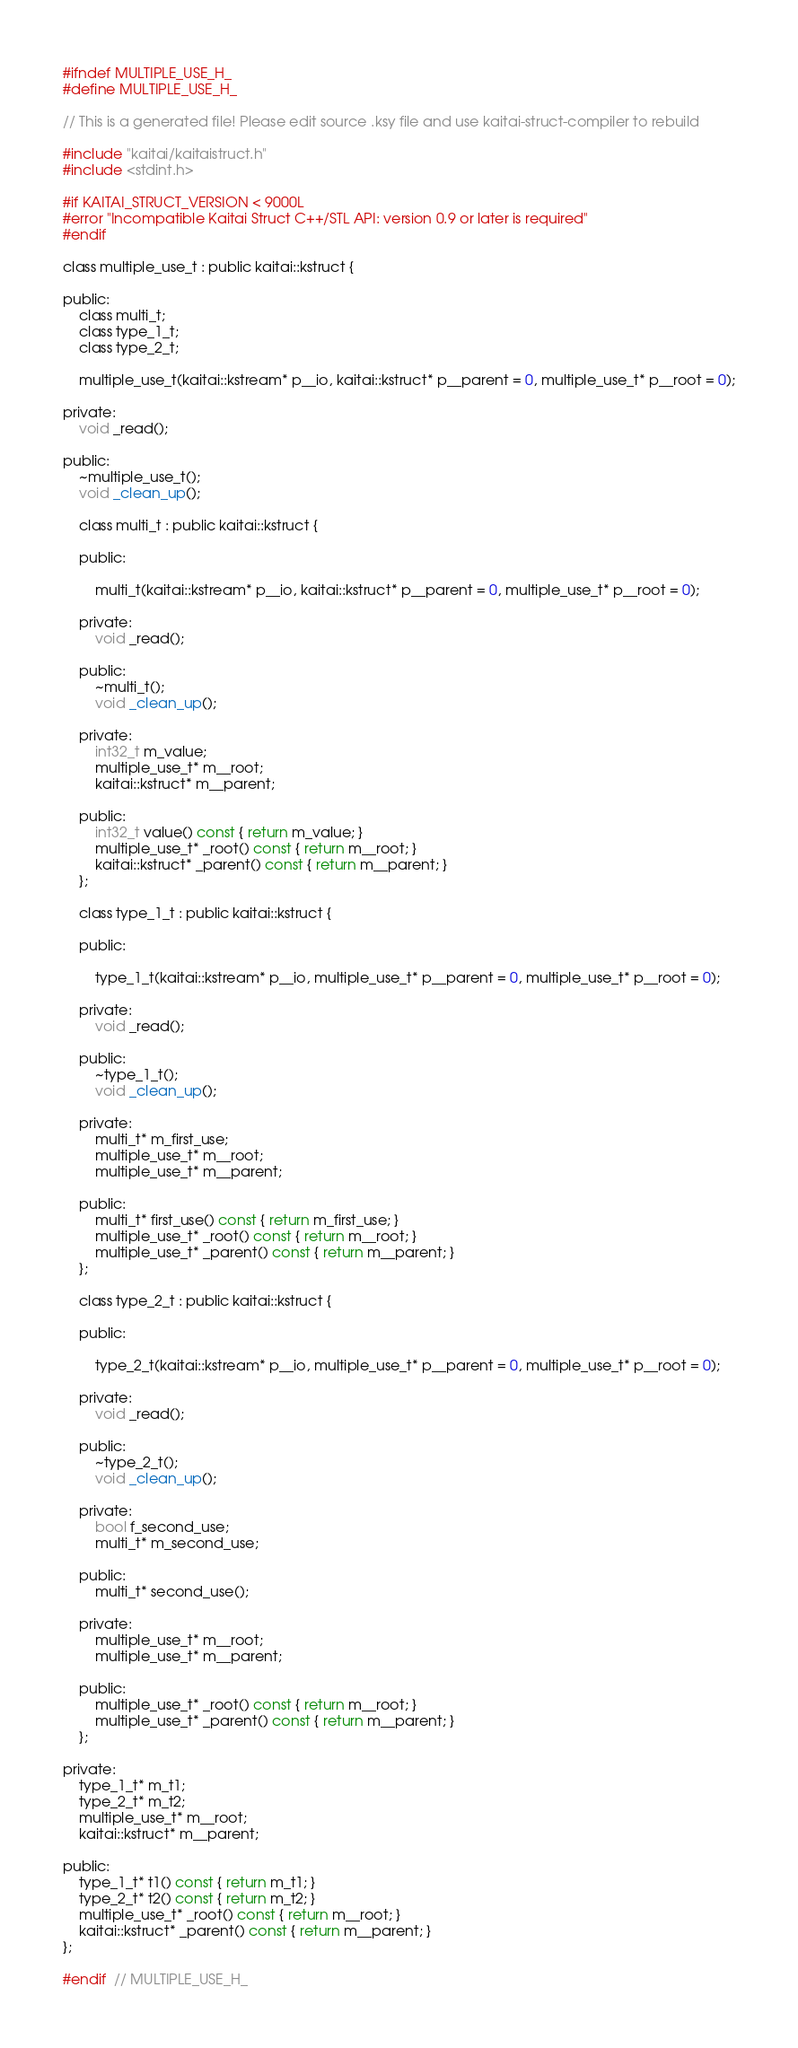<code> <loc_0><loc_0><loc_500><loc_500><_C_>#ifndef MULTIPLE_USE_H_
#define MULTIPLE_USE_H_

// This is a generated file! Please edit source .ksy file and use kaitai-struct-compiler to rebuild

#include "kaitai/kaitaistruct.h"
#include <stdint.h>

#if KAITAI_STRUCT_VERSION < 9000L
#error "Incompatible Kaitai Struct C++/STL API: version 0.9 or later is required"
#endif

class multiple_use_t : public kaitai::kstruct {

public:
    class multi_t;
    class type_1_t;
    class type_2_t;

    multiple_use_t(kaitai::kstream* p__io, kaitai::kstruct* p__parent = 0, multiple_use_t* p__root = 0);

private:
    void _read();

public:
    ~multiple_use_t();
    void _clean_up();

    class multi_t : public kaitai::kstruct {

    public:

        multi_t(kaitai::kstream* p__io, kaitai::kstruct* p__parent = 0, multiple_use_t* p__root = 0);

    private:
        void _read();

    public:
        ~multi_t();
        void _clean_up();

    private:
        int32_t m_value;
        multiple_use_t* m__root;
        kaitai::kstruct* m__parent;

    public:
        int32_t value() const { return m_value; }
        multiple_use_t* _root() const { return m__root; }
        kaitai::kstruct* _parent() const { return m__parent; }
    };

    class type_1_t : public kaitai::kstruct {

    public:

        type_1_t(kaitai::kstream* p__io, multiple_use_t* p__parent = 0, multiple_use_t* p__root = 0);

    private:
        void _read();

    public:
        ~type_1_t();
        void _clean_up();

    private:
        multi_t* m_first_use;
        multiple_use_t* m__root;
        multiple_use_t* m__parent;

    public:
        multi_t* first_use() const { return m_first_use; }
        multiple_use_t* _root() const { return m__root; }
        multiple_use_t* _parent() const { return m__parent; }
    };

    class type_2_t : public kaitai::kstruct {

    public:

        type_2_t(kaitai::kstream* p__io, multiple_use_t* p__parent = 0, multiple_use_t* p__root = 0);

    private:
        void _read();

    public:
        ~type_2_t();
        void _clean_up();

    private:
        bool f_second_use;
        multi_t* m_second_use;

    public:
        multi_t* second_use();

    private:
        multiple_use_t* m__root;
        multiple_use_t* m__parent;

    public:
        multiple_use_t* _root() const { return m__root; }
        multiple_use_t* _parent() const { return m__parent; }
    };

private:
    type_1_t* m_t1;
    type_2_t* m_t2;
    multiple_use_t* m__root;
    kaitai::kstruct* m__parent;

public:
    type_1_t* t1() const { return m_t1; }
    type_2_t* t2() const { return m_t2; }
    multiple_use_t* _root() const { return m__root; }
    kaitai::kstruct* _parent() const { return m__parent; }
};

#endif  // MULTIPLE_USE_H_
</code> 